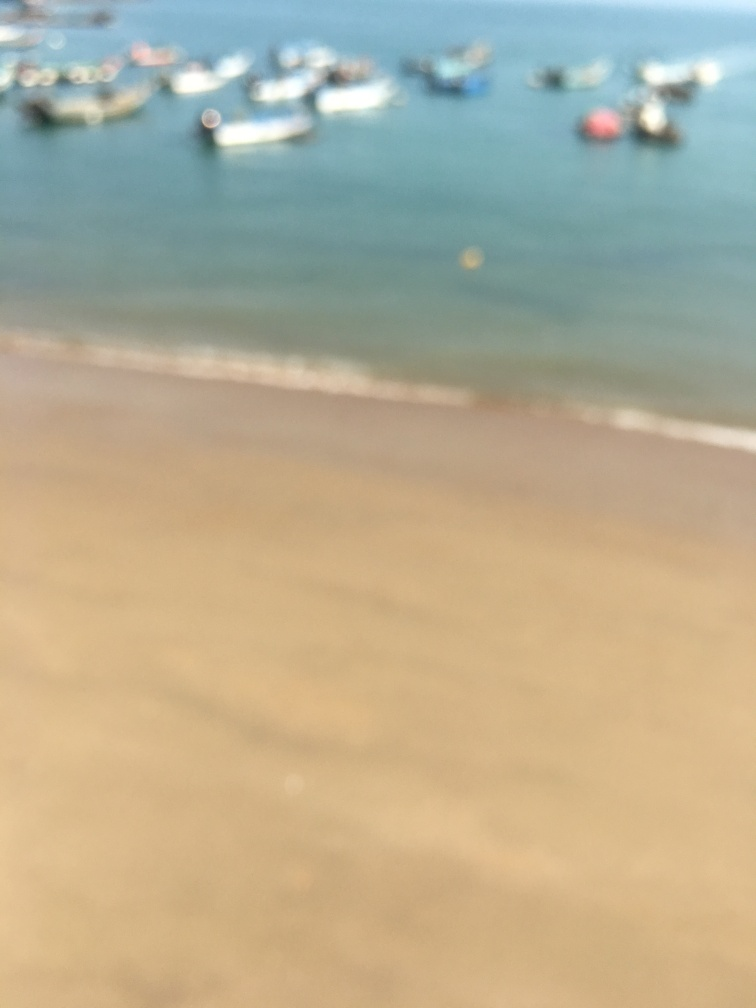What can be observed about the overall focus of this image?
A. Sharp
B. Crisp
C. Blurry
D. Clear
Answer with the option's letter from the given choices directly.
 C. 